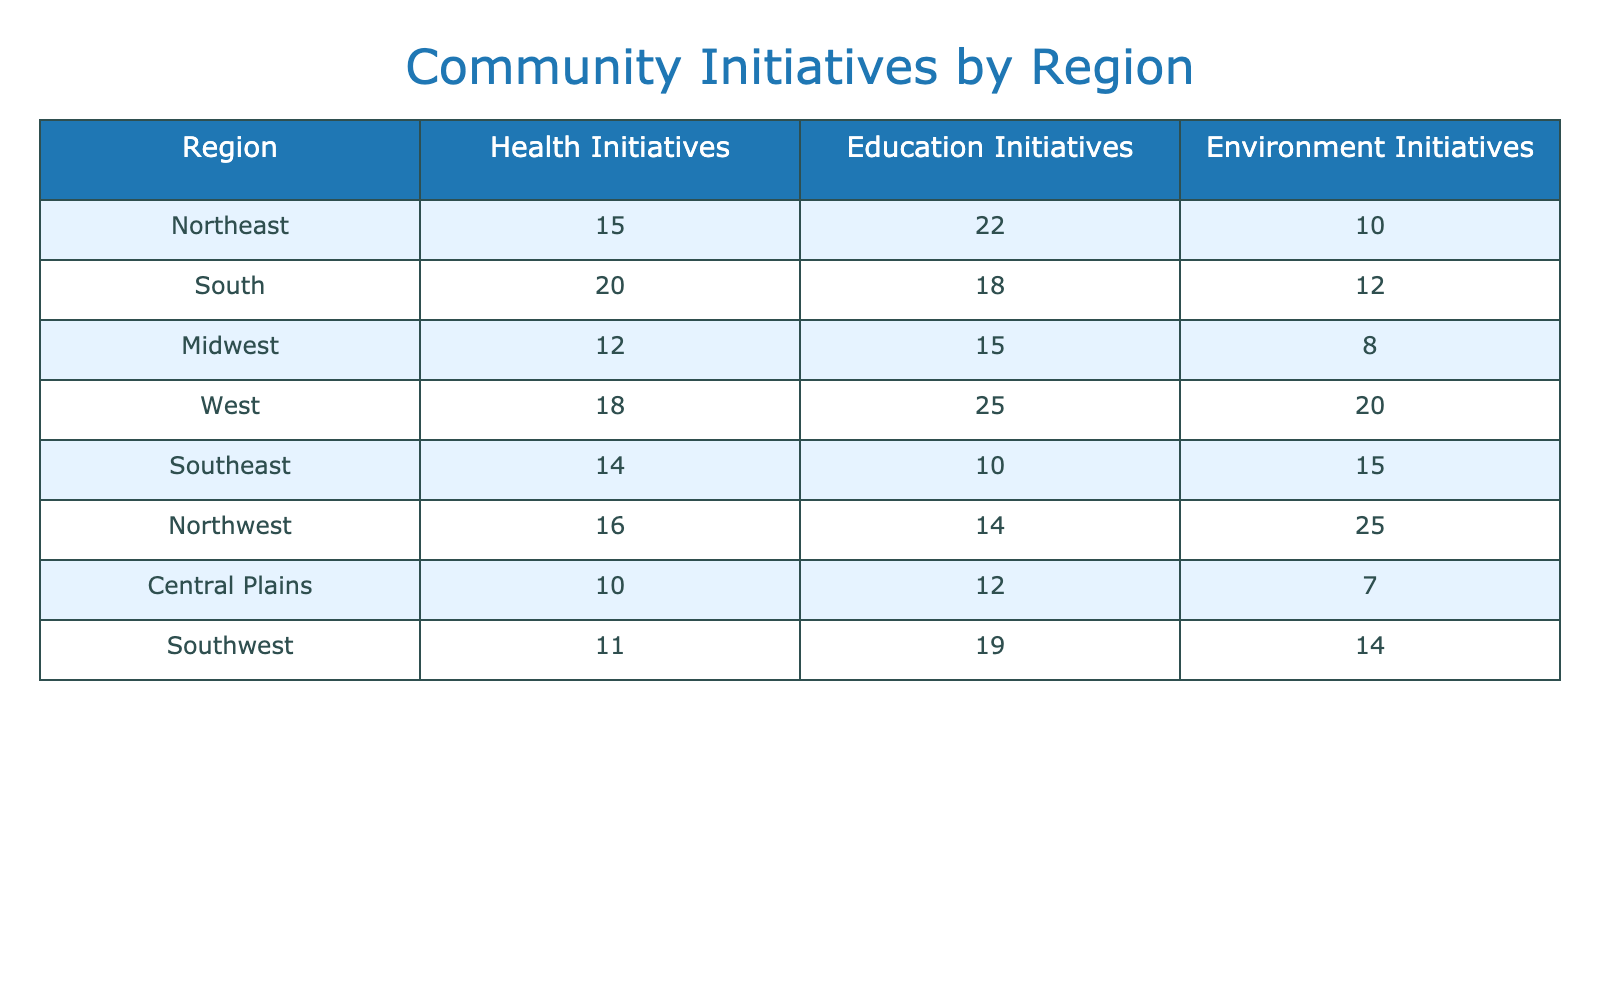What region has the highest number of health initiatives? By reviewing the "Health Initiatives" column, the highest value is 20, which corresponds to the South region.
Answer: South Which region implemented more education initiatives, the Northeast or the Midwest? The Northeast has 22 education initiatives, while the Midwest has 15. Therefore, the Northeast has more education initiatives.
Answer: Northeast What is the total number of environment initiatives implemented in the West and the Southeast combined? The West has 20 environment initiatives and the Southeast has 15. Adding these gives 20 + 15 = 35 total environment initiatives.
Answer: 35 How many more health initiatives did the South implement compared to the Central Plains? The South has 20 health initiatives, while the Central Plains has 10. The difference is 20 - 10 = 10 more health initiatives.
Answer: 10 Is there a region that has equal numbers of health and education initiatives? The region of Northwest has 16 health and 14 education initiatives, while others either have a difference or do not match. Hence, no region reports equal numbers.
Answer: No What is the average number of environment initiatives across all regions? Summing the environment initiatives (10 + 12 + 8 + 20 + 15 + 25 + 7 + 14 = 111) and dividing by the total number of regions (8), providing an average of 13.875.
Answer: 13.875 Which region has the least number of education initiatives? By checking the "Education Initiatives" column, the Central Plains has the least with only 12 initiatives compared to others.
Answer: Central Plains If you combine all initiatives in the Midwest, how many total initiatives does it have? Summing the initiatives for the Midwest: health (12) + education (15) + environment (8) equals a total of 35 initiatives.
Answer: 35 Are there more health initiatives in the Northeast than in the Northwest? The Northeast has 15 health initiatives while the Northwest has 16. Thus, the Northeast has fewer health initiatives than the Northwest.
Answer: No 